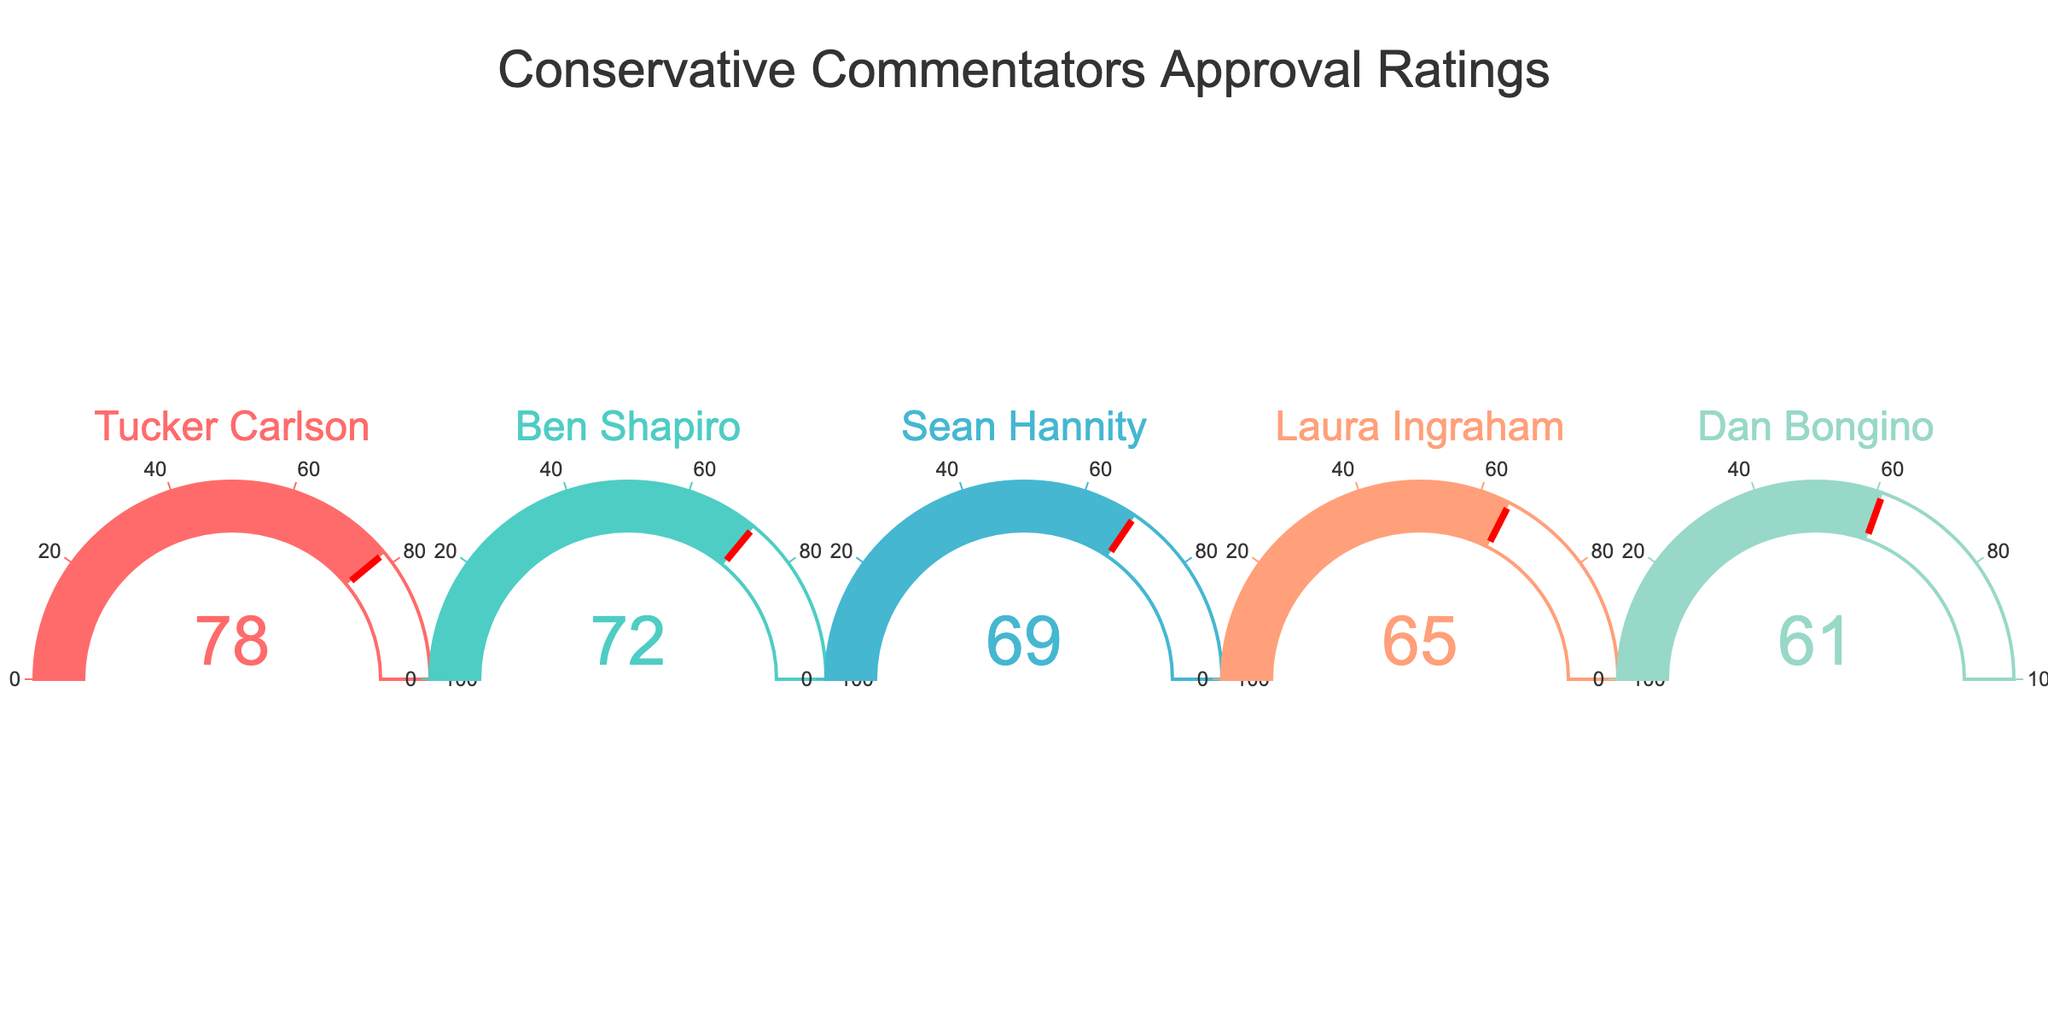Which conservative commentator has the highest approval rating? The figure shows gauges for several conservative commentators with their approval ratings. The gauge with the highest reading is for Tucker Carlson at 78.
Answer: Tucker Carlson Which commentator has the lowest approval rating? By looking at the gauges, the commentator with the lowest reading of the needle is Dan Bongino, with an approval rating of 61.
Answer: Dan Bongino What is the average approval rating among the five commentators? Adding all the approval ratings (78 + 72 + 69 + 65 + 61) equals 345. Dividing 345 by the 5 commentators gives an average of 69.
Answer: 69 How much higher is Tucker Carlson's approval rating compared to Laura Ingraham's? Tucker Carlson's rating is 78, and Laura Ingraham's rating is 65. The difference is 78 - 65, which is 13.
Answer: 13 Between Ben Shapiro and Sean Hannity, who has the higher approval rating and by how much? Ben Shapiro has a rating of 72, and Sean Hannity has a rating of 69. Shapiro's rating is higher, and the difference is 72 - 69, which is 3.
Answer: Ben Shapiro by 3 Is there any commentator with an approval rating over 80? By scanning the gauges, none of the approval ratings displayed exceed 80. The highest is 78 for Tucker Carlson.
Answer: No If these approval ratings were based on 100 voters, how many people approved of Dan Bongino? Dan Bongino's approval rating is 61. This translates to 61 out of 100 people approving of him.
Answer: 61 Are more than half of the commentators' approval ratings above 70? Out of the five commentators, Tucker Carlson (78) and Ben Shapiro (72) are above 70. Two out of five is less than half.
Answer: No What is the difference between the highest and lowest approval ratings? The highest rating is 78, and the lowest is 61. The difference is 78 - 61, which gives 17.
Answer: 17 